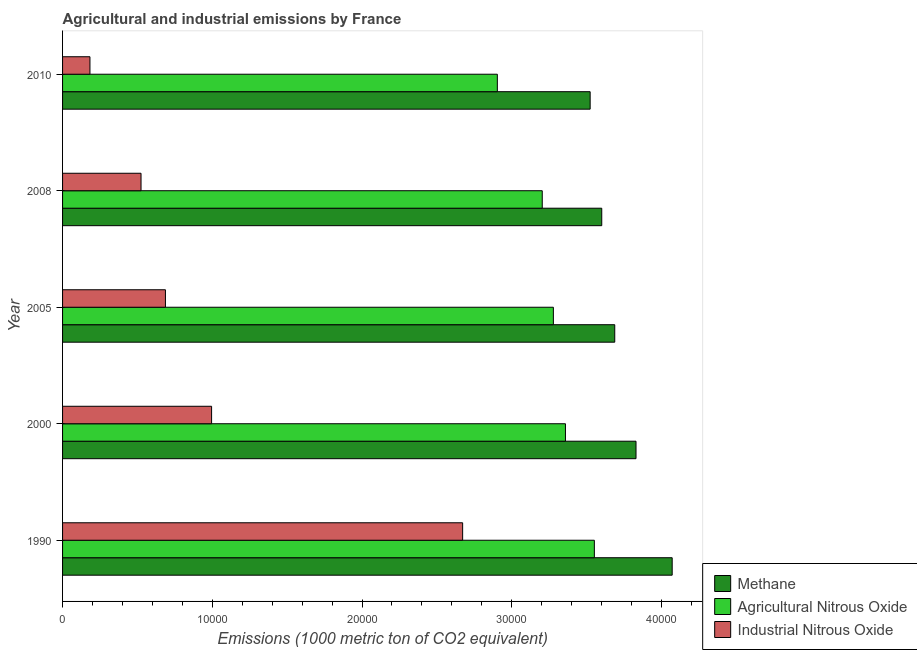How many different coloured bars are there?
Ensure brevity in your answer.  3. How many groups of bars are there?
Ensure brevity in your answer.  5. Are the number of bars per tick equal to the number of legend labels?
Your answer should be very brief. Yes. Are the number of bars on each tick of the Y-axis equal?
Your answer should be very brief. Yes. How many bars are there on the 4th tick from the bottom?
Provide a short and direct response. 3. In how many cases, is the number of bars for a given year not equal to the number of legend labels?
Your response must be concise. 0. What is the amount of methane emissions in 2000?
Ensure brevity in your answer.  3.83e+04. Across all years, what is the maximum amount of industrial nitrous oxide emissions?
Your response must be concise. 2.67e+04. Across all years, what is the minimum amount of methane emissions?
Your response must be concise. 3.52e+04. What is the total amount of industrial nitrous oxide emissions in the graph?
Provide a succinct answer. 5.06e+04. What is the difference between the amount of methane emissions in 1990 and that in 2005?
Make the answer very short. 3836.5. What is the difference between the amount of methane emissions in 2000 and the amount of industrial nitrous oxide emissions in 2010?
Make the answer very short. 3.65e+04. What is the average amount of industrial nitrous oxide emissions per year?
Your answer should be compact. 1.01e+04. In the year 1990, what is the difference between the amount of industrial nitrous oxide emissions and amount of methane emissions?
Provide a short and direct response. -1.40e+04. What is the difference between the highest and the second highest amount of industrial nitrous oxide emissions?
Your answer should be very brief. 1.68e+04. What is the difference between the highest and the lowest amount of industrial nitrous oxide emissions?
Your response must be concise. 2.49e+04. In how many years, is the amount of agricultural nitrous oxide emissions greater than the average amount of agricultural nitrous oxide emissions taken over all years?
Offer a terse response. 3. What does the 3rd bar from the top in 2008 represents?
Provide a short and direct response. Methane. What does the 2nd bar from the bottom in 2010 represents?
Offer a very short reply. Agricultural Nitrous Oxide. Are the values on the major ticks of X-axis written in scientific E-notation?
Provide a short and direct response. No. Does the graph contain grids?
Your answer should be very brief. No. Where does the legend appear in the graph?
Provide a succinct answer. Bottom right. How are the legend labels stacked?
Offer a very short reply. Vertical. What is the title of the graph?
Provide a short and direct response. Agricultural and industrial emissions by France. Does "Manufactures" appear as one of the legend labels in the graph?
Offer a terse response. No. What is the label or title of the X-axis?
Your answer should be compact. Emissions (1000 metric ton of CO2 equivalent). What is the label or title of the Y-axis?
Your answer should be very brief. Year. What is the Emissions (1000 metric ton of CO2 equivalent) of Methane in 1990?
Give a very brief answer. 4.07e+04. What is the Emissions (1000 metric ton of CO2 equivalent) of Agricultural Nitrous Oxide in 1990?
Keep it short and to the point. 3.55e+04. What is the Emissions (1000 metric ton of CO2 equivalent) in Industrial Nitrous Oxide in 1990?
Your response must be concise. 2.67e+04. What is the Emissions (1000 metric ton of CO2 equivalent) in Methane in 2000?
Offer a very short reply. 3.83e+04. What is the Emissions (1000 metric ton of CO2 equivalent) in Agricultural Nitrous Oxide in 2000?
Provide a succinct answer. 3.36e+04. What is the Emissions (1000 metric ton of CO2 equivalent) of Industrial Nitrous Oxide in 2000?
Offer a terse response. 9953.8. What is the Emissions (1000 metric ton of CO2 equivalent) of Methane in 2005?
Offer a very short reply. 3.69e+04. What is the Emissions (1000 metric ton of CO2 equivalent) of Agricultural Nitrous Oxide in 2005?
Make the answer very short. 3.28e+04. What is the Emissions (1000 metric ton of CO2 equivalent) in Industrial Nitrous Oxide in 2005?
Provide a succinct answer. 6871.6. What is the Emissions (1000 metric ton of CO2 equivalent) of Methane in 2008?
Your answer should be very brief. 3.60e+04. What is the Emissions (1000 metric ton of CO2 equivalent) in Agricultural Nitrous Oxide in 2008?
Ensure brevity in your answer.  3.20e+04. What is the Emissions (1000 metric ton of CO2 equivalent) in Industrial Nitrous Oxide in 2008?
Offer a terse response. 5241.3. What is the Emissions (1000 metric ton of CO2 equivalent) in Methane in 2010?
Offer a very short reply. 3.52e+04. What is the Emissions (1000 metric ton of CO2 equivalent) of Agricultural Nitrous Oxide in 2010?
Provide a succinct answer. 2.90e+04. What is the Emissions (1000 metric ton of CO2 equivalent) in Industrial Nitrous Oxide in 2010?
Your answer should be compact. 1828.8. Across all years, what is the maximum Emissions (1000 metric ton of CO2 equivalent) of Methane?
Give a very brief answer. 4.07e+04. Across all years, what is the maximum Emissions (1000 metric ton of CO2 equivalent) in Agricultural Nitrous Oxide?
Provide a short and direct response. 3.55e+04. Across all years, what is the maximum Emissions (1000 metric ton of CO2 equivalent) of Industrial Nitrous Oxide?
Your answer should be very brief. 2.67e+04. Across all years, what is the minimum Emissions (1000 metric ton of CO2 equivalent) of Methane?
Your answer should be compact. 3.52e+04. Across all years, what is the minimum Emissions (1000 metric ton of CO2 equivalent) of Agricultural Nitrous Oxide?
Your answer should be compact. 2.90e+04. Across all years, what is the minimum Emissions (1000 metric ton of CO2 equivalent) in Industrial Nitrous Oxide?
Offer a terse response. 1828.8. What is the total Emissions (1000 metric ton of CO2 equivalent) in Methane in the graph?
Your answer should be compact. 1.87e+05. What is the total Emissions (1000 metric ton of CO2 equivalent) of Agricultural Nitrous Oxide in the graph?
Offer a very short reply. 1.63e+05. What is the total Emissions (1000 metric ton of CO2 equivalent) of Industrial Nitrous Oxide in the graph?
Offer a terse response. 5.06e+04. What is the difference between the Emissions (1000 metric ton of CO2 equivalent) in Methane in 1990 and that in 2000?
Make the answer very short. 2415.3. What is the difference between the Emissions (1000 metric ton of CO2 equivalent) in Agricultural Nitrous Oxide in 1990 and that in 2000?
Offer a terse response. 1930.3. What is the difference between the Emissions (1000 metric ton of CO2 equivalent) in Industrial Nitrous Oxide in 1990 and that in 2000?
Your answer should be very brief. 1.68e+04. What is the difference between the Emissions (1000 metric ton of CO2 equivalent) of Methane in 1990 and that in 2005?
Keep it short and to the point. 3836.5. What is the difference between the Emissions (1000 metric ton of CO2 equivalent) of Agricultural Nitrous Oxide in 1990 and that in 2005?
Offer a very short reply. 2736.8. What is the difference between the Emissions (1000 metric ton of CO2 equivalent) in Industrial Nitrous Oxide in 1990 and that in 2005?
Your answer should be very brief. 1.99e+04. What is the difference between the Emissions (1000 metric ton of CO2 equivalent) in Methane in 1990 and that in 2008?
Your response must be concise. 4704.7. What is the difference between the Emissions (1000 metric ton of CO2 equivalent) in Agricultural Nitrous Oxide in 1990 and that in 2008?
Provide a short and direct response. 3480.3. What is the difference between the Emissions (1000 metric ton of CO2 equivalent) of Industrial Nitrous Oxide in 1990 and that in 2008?
Offer a terse response. 2.15e+04. What is the difference between the Emissions (1000 metric ton of CO2 equivalent) of Methane in 1990 and that in 2010?
Give a very brief answer. 5479. What is the difference between the Emissions (1000 metric ton of CO2 equivalent) of Agricultural Nitrous Oxide in 1990 and that in 2010?
Keep it short and to the point. 6479.5. What is the difference between the Emissions (1000 metric ton of CO2 equivalent) in Industrial Nitrous Oxide in 1990 and that in 2010?
Your answer should be very brief. 2.49e+04. What is the difference between the Emissions (1000 metric ton of CO2 equivalent) of Methane in 2000 and that in 2005?
Give a very brief answer. 1421.2. What is the difference between the Emissions (1000 metric ton of CO2 equivalent) of Agricultural Nitrous Oxide in 2000 and that in 2005?
Your answer should be very brief. 806.5. What is the difference between the Emissions (1000 metric ton of CO2 equivalent) of Industrial Nitrous Oxide in 2000 and that in 2005?
Keep it short and to the point. 3082.2. What is the difference between the Emissions (1000 metric ton of CO2 equivalent) in Methane in 2000 and that in 2008?
Keep it short and to the point. 2289.4. What is the difference between the Emissions (1000 metric ton of CO2 equivalent) of Agricultural Nitrous Oxide in 2000 and that in 2008?
Offer a very short reply. 1550. What is the difference between the Emissions (1000 metric ton of CO2 equivalent) in Industrial Nitrous Oxide in 2000 and that in 2008?
Your answer should be compact. 4712.5. What is the difference between the Emissions (1000 metric ton of CO2 equivalent) in Methane in 2000 and that in 2010?
Your response must be concise. 3063.7. What is the difference between the Emissions (1000 metric ton of CO2 equivalent) in Agricultural Nitrous Oxide in 2000 and that in 2010?
Give a very brief answer. 4549.2. What is the difference between the Emissions (1000 metric ton of CO2 equivalent) of Industrial Nitrous Oxide in 2000 and that in 2010?
Provide a succinct answer. 8125. What is the difference between the Emissions (1000 metric ton of CO2 equivalent) in Methane in 2005 and that in 2008?
Make the answer very short. 868.2. What is the difference between the Emissions (1000 metric ton of CO2 equivalent) of Agricultural Nitrous Oxide in 2005 and that in 2008?
Your answer should be very brief. 743.5. What is the difference between the Emissions (1000 metric ton of CO2 equivalent) in Industrial Nitrous Oxide in 2005 and that in 2008?
Ensure brevity in your answer.  1630.3. What is the difference between the Emissions (1000 metric ton of CO2 equivalent) of Methane in 2005 and that in 2010?
Give a very brief answer. 1642.5. What is the difference between the Emissions (1000 metric ton of CO2 equivalent) of Agricultural Nitrous Oxide in 2005 and that in 2010?
Provide a succinct answer. 3742.7. What is the difference between the Emissions (1000 metric ton of CO2 equivalent) in Industrial Nitrous Oxide in 2005 and that in 2010?
Offer a very short reply. 5042.8. What is the difference between the Emissions (1000 metric ton of CO2 equivalent) in Methane in 2008 and that in 2010?
Your answer should be very brief. 774.3. What is the difference between the Emissions (1000 metric ton of CO2 equivalent) of Agricultural Nitrous Oxide in 2008 and that in 2010?
Offer a terse response. 2999.2. What is the difference between the Emissions (1000 metric ton of CO2 equivalent) in Industrial Nitrous Oxide in 2008 and that in 2010?
Your answer should be compact. 3412.5. What is the difference between the Emissions (1000 metric ton of CO2 equivalent) in Methane in 1990 and the Emissions (1000 metric ton of CO2 equivalent) in Agricultural Nitrous Oxide in 2000?
Offer a very short reply. 7128.7. What is the difference between the Emissions (1000 metric ton of CO2 equivalent) of Methane in 1990 and the Emissions (1000 metric ton of CO2 equivalent) of Industrial Nitrous Oxide in 2000?
Make the answer very short. 3.08e+04. What is the difference between the Emissions (1000 metric ton of CO2 equivalent) in Agricultural Nitrous Oxide in 1990 and the Emissions (1000 metric ton of CO2 equivalent) in Industrial Nitrous Oxide in 2000?
Make the answer very short. 2.56e+04. What is the difference between the Emissions (1000 metric ton of CO2 equivalent) of Methane in 1990 and the Emissions (1000 metric ton of CO2 equivalent) of Agricultural Nitrous Oxide in 2005?
Your answer should be very brief. 7935.2. What is the difference between the Emissions (1000 metric ton of CO2 equivalent) of Methane in 1990 and the Emissions (1000 metric ton of CO2 equivalent) of Industrial Nitrous Oxide in 2005?
Offer a very short reply. 3.38e+04. What is the difference between the Emissions (1000 metric ton of CO2 equivalent) in Agricultural Nitrous Oxide in 1990 and the Emissions (1000 metric ton of CO2 equivalent) in Industrial Nitrous Oxide in 2005?
Make the answer very short. 2.86e+04. What is the difference between the Emissions (1000 metric ton of CO2 equivalent) of Methane in 1990 and the Emissions (1000 metric ton of CO2 equivalent) of Agricultural Nitrous Oxide in 2008?
Your response must be concise. 8678.7. What is the difference between the Emissions (1000 metric ton of CO2 equivalent) in Methane in 1990 and the Emissions (1000 metric ton of CO2 equivalent) in Industrial Nitrous Oxide in 2008?
Ensure brevity in your answer.  3.55e+04. What is the difference between the Emissions (1000 metric ton of CO2 equivalent) of Agricultural Nitrous Oxide in 1990 and the Emissions (1000 metric ton of CO2 equivalent) of Industrial Nitrous Oxide in 2008?
Offer a very short reply. 3.03e+04. What is the difference between the Emissions (1000 metric ton of CO2 equivalent) of Methane in 1990 and the Emissions (1000 metric ton of CO2 equivalent) of Agricultural Nitrous Oxide in 2010?
Make the answer very short. 1.17e+04. What is the difference between the Emissions (1000 metric ton of CO2 equivalent) in Methane in 1990 and the Emissions (1000 metric ton of CO2 equivalent) in Industrial Nitrous Oxide in 2010?
Ensure brevity in your answer.  3.89e+04. What is the difference between the Emissions (1000 metric ton of CO2 equivalent) of Agricultural Nitrous Oxide in 1990 and the Emissions (1000 metric ton of CO2 equivalent) of Industrial Nitrous Oxide in 2010?
Keep it short and to the point. 3.37e+04. What is the difference between the Emissions (1000 metric ton of CO2 equivalent) in Methane in 2000 and the Emissions (1000 metric ton of CO2 equivalent) in Agricultural Nitrous Oxide in 2005?
Offer a very short reply. 5519.9. What is the difference between the Emissions (1000 metric ton of CO2 equivalent) in Methane in 2000 and the Emissions (1000 metric ton of CO2 equivalent) in Industrial Nitrous Oxide in 2005?
Your answer should be compact. 3.14e+04. What is the difference between the Emissions (1000 metric ton of CO2 equivalent) in Agricultural Nitrous Oxide in 2000 and the Emissions (1000 metric ton of CO2 equivalent) in Industrial Nitrous Oxide in 2005?
Offer a very short reply. 2.67e+04. What is the difference between the Emissions (1000 metric ton of CO2 equivalent) in Methane in 2000 and the Emissions (1000 metric ton of CO2 equivalent) in Agricultural Nitrous Oxide in 2008?
Provide a short and direct response. 6263.4. What is the difference between the Emissions (1000 metric ton of CO2 equivalent) in Methane in 2000 and the Emissions (1000 metric ton of CO2 equivalent) in Industrial Nitrous Oxide in 2008?
Offer a terse response. 3.31e+04. What is the difference between the Emissions (1000 metric ton of CO2 equivalent) of Agricultural Nitrous Oxide in 2000 and the Emissions (1000 metric ton of CO2 equivalent) of Industrial Nitrous Oxide in 2008?
Make the answer very short. 2.83e+04. What is the difference between the Emissions (1000 metric ton of CO2 equivalent) of Methane in 2000 and the Emissions (1000 metric ton of CO2 equivalent) of Agricultural Nitrous Oxide in 2010?
Offer a very short reply. 9262.6. What is the difference between the Emissions (1000 metric ton of CO2 equivalent) in Methane in 2000 and the Emissions (1000 metric ton of CO2 equivalent) in Industrial Nitrous Oxide in 2010?
Make the answer very short. 3.65e+04. What is the difference between the Emissions (1000 metric ton of CO2 equivalent) of Agricultural Nitrous Oxide in 2000 and the Emissions (1000 metric ton of CO2 equivalent) of Industrial Nitrous Oxide in 2010?
Ensure brevity in your answer.  3.18e+04. What is the difference between the Emissions (1000 metric ton of CO2 equivalent) of Methane in 2005 and the Emissions (1000 metric ton of CO2 equivalent) of Agricultural Nitrous Oxide in 2008?
Offer a very short reply. 4842.2. What is the difference between the Emissions (1000 metric ton of CO2 equivalent) in Methane in 2005 and the Emissions (1000 metric ton of CO2 equivalent) in Industrial Nitrous Oxide in 2008?
Offer a terse response. 3.16e+04. What is the difference between the Emissions (1000 metric ton of CO2 equivalent) of Agricultural Nitrous Oxide in 2005 and the Emissions (1000 metric ton of CO2 equivalent) of Industrial Nitrous Oxide in 2008?
Offer a very short reply. 2.75e+04. What is the difference between the Emissions (1000 metric ton of CO2 equivalent) of Methane in 2005 and the Emissions (1000 metric ton of CO2 equivalent) of Agricultural Nitrous Oxide in 2010?
Provide a succinct answer. 7841.4. What is the difference between the Emissions (1000 metric ton of CO2 equivalent) of Methane in 2005 and the Emissions (1000 metric ton of CO2 equivalent) of Industrial Nitrous Oxide in 2010?
Keep it short and to the point. 3.51e+04. What is the difference between the Emissions (1000 metric ton of CO2 equivalent) of Agricultural Nitrous Oxide in 2005 and the Emissions (1000 metric ton of CO2 equivalent) of Industrial Nitrous Oxide in 2010?
Offer a very short reply. 3.10e+04. What is the difference between the Emissions (1000 metric ton of CO2 equivalent) in Methane in 2008 and the Emissions (1000 metric ton of CO2 equivalent) in Agricultural Nitrous Oxide in 2010?
Provide a short and direct response. 6973.2. What is the difference between the Emissions (1000 metric ton of CO2 equivalent) in Methane in 2008 and the Emissions (1000 metric ton of CO2 equivalent) in Industrial Nitrous Oxide in 2010?
Your answer should be very brief. 3.42e+04. What is the difference between the Emissions (1000 metric ton of CO2 equivalent) in Agricultural Nitrous Oxide in 2008 and the Emissions (1000 metric ton of CO2 equivalent) in Industrial Nitrous Oxide in 2010?
Your answer should be compact. 3.02e+04. What is the average Emissions (1000 metric ton of CO2 equivalent) of Methane per year?
Give a very brief answer. 3.74e+04. What is the average Emissions (1000 metric ton of CO2 equivalent) in Agricultural Nitrous Oxide per year?
Your answer should be compact. 3.26e+04. What is the average Emissions (1000 metric ton of CO2 equivalent) of Industrial Nitrous Oxide per year?
Offer a very short reply. 1.01e+04. In the year 1990, what is the difference between the Emissions (1000 metric ton of CO2 equivalent) in Methane and Emissions (1000 metric ton of CO2 equivalent) in Agricultural Nitrous Oxide?
Provide a short and direct response. 5198.4. In the year 1990, what is the difference between the Emissions (1000 metric ton of CO2 equivalent) of Methane and Emissions (1000 metric ton of CO2 equivalent) of Industrial Nitrous Oxide?
Your answer should be very brief. 1.40e+04. In the year 1990, what is the difference between the Emissions (1000 metric ton of CO2 equivalent) of Agricultural Nitrous Oxide and Emissions (1000 metric ton of CO2 equivalent) of Industrial Nitrous Oxide?
Offer a terse response. 8797.6. In the year 2000, what is the difference between the Emissions (1000 metric ton of CO2 equivalent) in Methane and Emissions (1000 metric ton of CO2 equivalent) in Agricultural Nitrous Oxide?
Your answer should be very brief. 4713.4. In the year 2000, what is the difference between the Emissions (1000 metric ton of CO2 equivalent) in Methane and Emissions (1000 metric ton of CO2 equivalent) in Industrial Nitrous Oxide?
Your answer should be compact. 2.83e+04. In the year 2000, what is the difference between the Emissions (1000 metric ton of CO2 equivalent) of Agricultural Nitrous Oxide and Emissions (1000 metric ton of CO2 equivalent) of Industrial Nitrous Oxide?
Ensure brevity in your answer.  2.36e+04. In the year 2005, what is the difference between the Emissions (1000 metric ton of CO2 equivalent) of Methane and Emissions (1000 metric ton of CO2 equivalent) of Agricultural Nitrous Oxide?
Your answer should be very brief. 4098.7. In the year 2005, what is the difference between the Emissions (1000 metric ton of CO2 equivalent) in Methane and Emissions (1000 metric ton of CO2 equivalent) in Industrial Nitrous Oxide?
Ensure brevity in your answer.  3.00e+04. In the year 2005, what is the difference between the Emissions (1000 metric ton of CO2 equivalent) in Agricultural Nitrous Oxide and Emissions (1000 metric ton of CO2 equivalent) in Industrial Nitrous Oxide?
Your answer should be compact. 2.59e+04. In the year 2008, what is the difference between the Emissions (1000 metric ton of CO2 equivalent) of Methane and Emissions (1000 metric ton of CO2 equivalent) of Agricultural Nitrous Oxide?
Offer a terse response. 3974. In the year 2008, what is the difference between the Emissions (1000 metric ton of CO2 equivalent) of Methane and Emissions (1000 metric ton of CO2 equivalent) of Industrial Nitrous Oxide?
Provide a short and direct response. 3.08e+04. In the year 2008, what is the difference between the Emissions (1000 metric ton of CO2 equivalent) in Agricultural Nitrous Oxide and Emissions (1000 metric ton of CO2 equivalent) in Industrial Nitrous Oxide?
Offer a very short reply. 2.68e+04. In the year 2010, what is the difference between the Emissions (1000 metric ton of CO2 equivalent) of Methane and Emissions (1000 metric ton of CO2 equivalent) of Agricultural Nitrous Oxide?
Ensure brevity in your answer.  6198.9. In the year 2010, what is the difference between the Emissions (1000 metric ton of CO2 equivalent) in Methane and Emissions (1000 metric ton of CO2 equivalent) in Industrial Nitrous Oxide?
Offer a terse response. 3.34e+04. In the year 2010, what is the difference between the Emissions (1000 metric ton of CO2 equivalent) in Agricultural Nitrous Oxide and Emissions (1000 metric ton of CO2 equivalent) in Industrial Nitrous Oxide?
Provide a short and direct response. 2.72e+04. What is the ratio of the Emissions (1000 metric ton of CO2 equivalent) in Methane in 1990 to that in 2000?
Your response must be concise. 1.06. What is the ratio of the Emissions (1000 metric ton of CO2 equivalent) of Agricultural Nitrous Oxide in 1990 to that in 2000?
Offer a very short reply. 1.06. What is the ratio of the Emissions (1000 metric ton of CO2 equivalent) in Industrial Nitrous Oxide in 1990 to that in 2000?
Provide a short and direct response. 2.68. What is the ratio of the Emissions (1000 metric ton of CO2 equivalent) in Methane in 1990 to that in 2005?
Offer a very short reply. 1.1. What is the ratio of the Emissions (1000 metric ton of CO2 equivalent) of Agricultural Nitrous Oxide in 1990 to that in 2005?
Provide a succinct answer. 1.08. What is the ratio of the Emissions (1000 metric ton of CO2 equivalent) in Industrial Nitrous Oxide in 1990 to that in 2005?
Keep it short and to the point. 3.89. What is the ratio of the Emissions (1000 metric ton of CO2 equivalent) in Methane in 1990 to that in 2008?
Provide a short and direct response. 1.13. What is the ratio of the Emissions (1000 metric ton of CO2 equivalent) of Agricultural Nitrous Oxide in 1990 to that in 2008?
Your answer should be very brief. 1.11. What is the ratio of the Emissions (1000 metric ton of CO2 equivalent) of Industrial Nitrous Oxide in 1990 to that in 2008?
Your answer should be very brief. 5.1. What is the ratio of the Emissions (1000 metric ton of CO2 equivalent) of Methane in 1990 to that in 2010?
Your response must be concise. 1.16. What is the ratio of the Emissions (1000 metric ton of CO2 equivalent) in Agricultural Nitrous Oxide in 1990 to that in 2010?
Your response must be concise. 1.22. What is the ratio of the Emissions (1000 metric ton of CO2 equivalent) in Industrial Nitrous Oxide in 1990 to that in 2010?
Make the answer very short. 14.61. What is the ratio of the Emissions (1000 metric ton of CO2 equivalent) of Agricultural Nitrous Oxide in 2000 to that in 2005?
Your answer should be compact. 1.02. What is the ratio of the Emissions (1000 metric ton of CO2 equivalent) of Industrial Nitrous Oxide in 2000 to that in 2005?
Give a very brief answer. 1.45. What is the ratio of the Emissions (1000 metric ton of CO2 equivalent) of Methane in 2000 to that in 2008?
Give a very brief answer. 1.06. What is the ratio of the Emissions (1000 metric ton of CO2 equivalent) of Agricultural Nitrous Oxide in 2000 to that in 2008?
Give a very brief answer. 1.05. What is the ratio of the Emissions (1000 metric ton of CO2 equivalent) of Industrial Nitrous Oxide in 2000 to that in 2008?
Give a very brief answer. 1.9. What is the ratio of the Emissions (1000 metric ton of CO2 equivalent) of Methane in 2000 to that in 2010?
Provide a succinct answer. 1.09. What is the ratio of the Emissions (1000 metric ton of CO2 equivalent) of Agricultural Nitrous Oxide in 2000 to that in 2010?
Offer a terse response. 1.16. What is the ratio of the Emissions (1000 metric ton of CO2 equivalent) in Industrial Nitrous Oxide in 2000 to that in 2010?
Keep it short and to the point. 5.44. What is the ratio of the Emissions (1000 metric ton of CO2 equivalent) in Methane in 2005 to that in 2008?
Ensure brevity in your answer.  1.02. What is the ratio of the Emissions (1000 metric ton of CO2 equivalent) of Agricultural Nitrous Oxide in 2005 to that in 2008?
Provide a short and direct response. 1.02. What is the ratio of the Emissions (1000 metric ton of CO2 equivalent) of Industrial Nitrous Oxide in 2005 to that in 2008?
Offer a very short reply. 1.31. What is the ratio of the Emissions (1000 metric ton of CO2 equivalent) of Methane in 2005 to that in 2010?
Your response must be concise. 1.05. What is the ratio of the Emissions (1000 metric ton of CO2 equivalent) in Agricultural Nitrous Oxide in 2005 to that in 2010?
Offer a terse response. 1.13. What is the ratio of the Emissions (1000 metric ton of CO2 equivalent) in Industrial Nitrous Oxide in 2005 to that in 2010?
Offer a terse response. 3.76. What is the ratio of the Emissions (1000 metric ton of CO2 equivalent) of Agricultural Nitrous Oxide in 2008 to that in 2010?
Offer a terse response. 1.1. What is the ratio of the Emissions (1000 metric ton of CO2 equivalent) of Industrial Nitrous Oxide in 2008 to that in 2010?
Your answer should be very brief. 2.87. What is the difference between the highest and the second highest Emissions (1000 metric ton of CO2 equivalent) of Methane?
Offer a very short reply. 2415.3. What is the difference between the highest and the second highest Emissions (1000 metric ton of CO2 equivalent) in Agricultural Nitrous Oxide?
Give a very brief answer. 1930.3. What is the difference between the highest and the second highest Emissions (1000 metric ton of CO2 equivalent) in Industrial Nitrous Oxide?
Provide a short and direct response. 1.68e+04. What is the difference between the highest and the lowest Emissions (1000 metric ton of CO2 equivalent) of Methane?
Offer a terse response. 5479. What is the difference between the highest and the lowest Emissions (1000 metric ton of CO2 equivalent) in Agricultural Nitrous Oxide?
Provide a succinct answer. 6479.5. What is the difference between the highest and the lowest Emissions (1000 metric ton of CO2 equivalent) of Industrial Nitrous Oxide?
Offer a very short reply. 2.49e+04. 